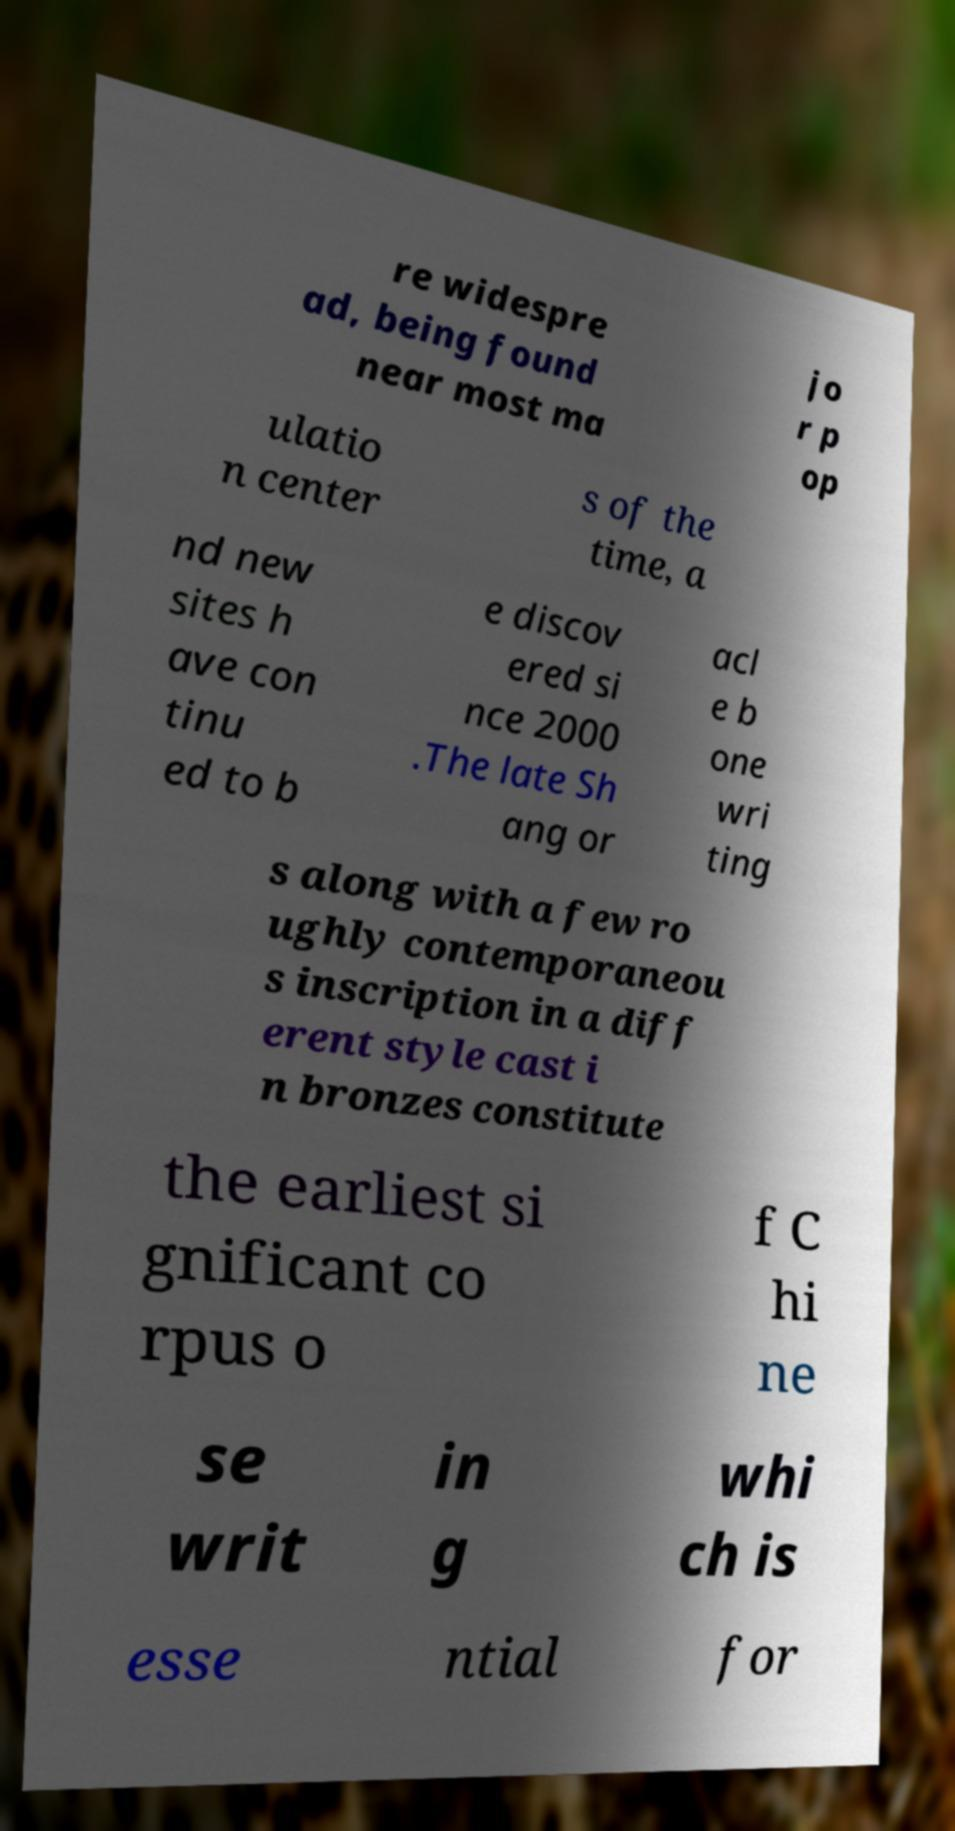Could you assist in decoding the text presented in this image and type it out clearly? re widespre ad, being found near most ma jo r p op ulatio n center s of the time, a nd new sites h ave con tinu ed to b e discov ered si nce 2000 .The late Sh ang or acl e b one wri ting s along with a few ro ughly contemporaneou s inscription in a diff erent style cast i n bronzes constitute the earliest si gnificant co rpus o f C hi ne se writ in g whi ch is esse ntial for 